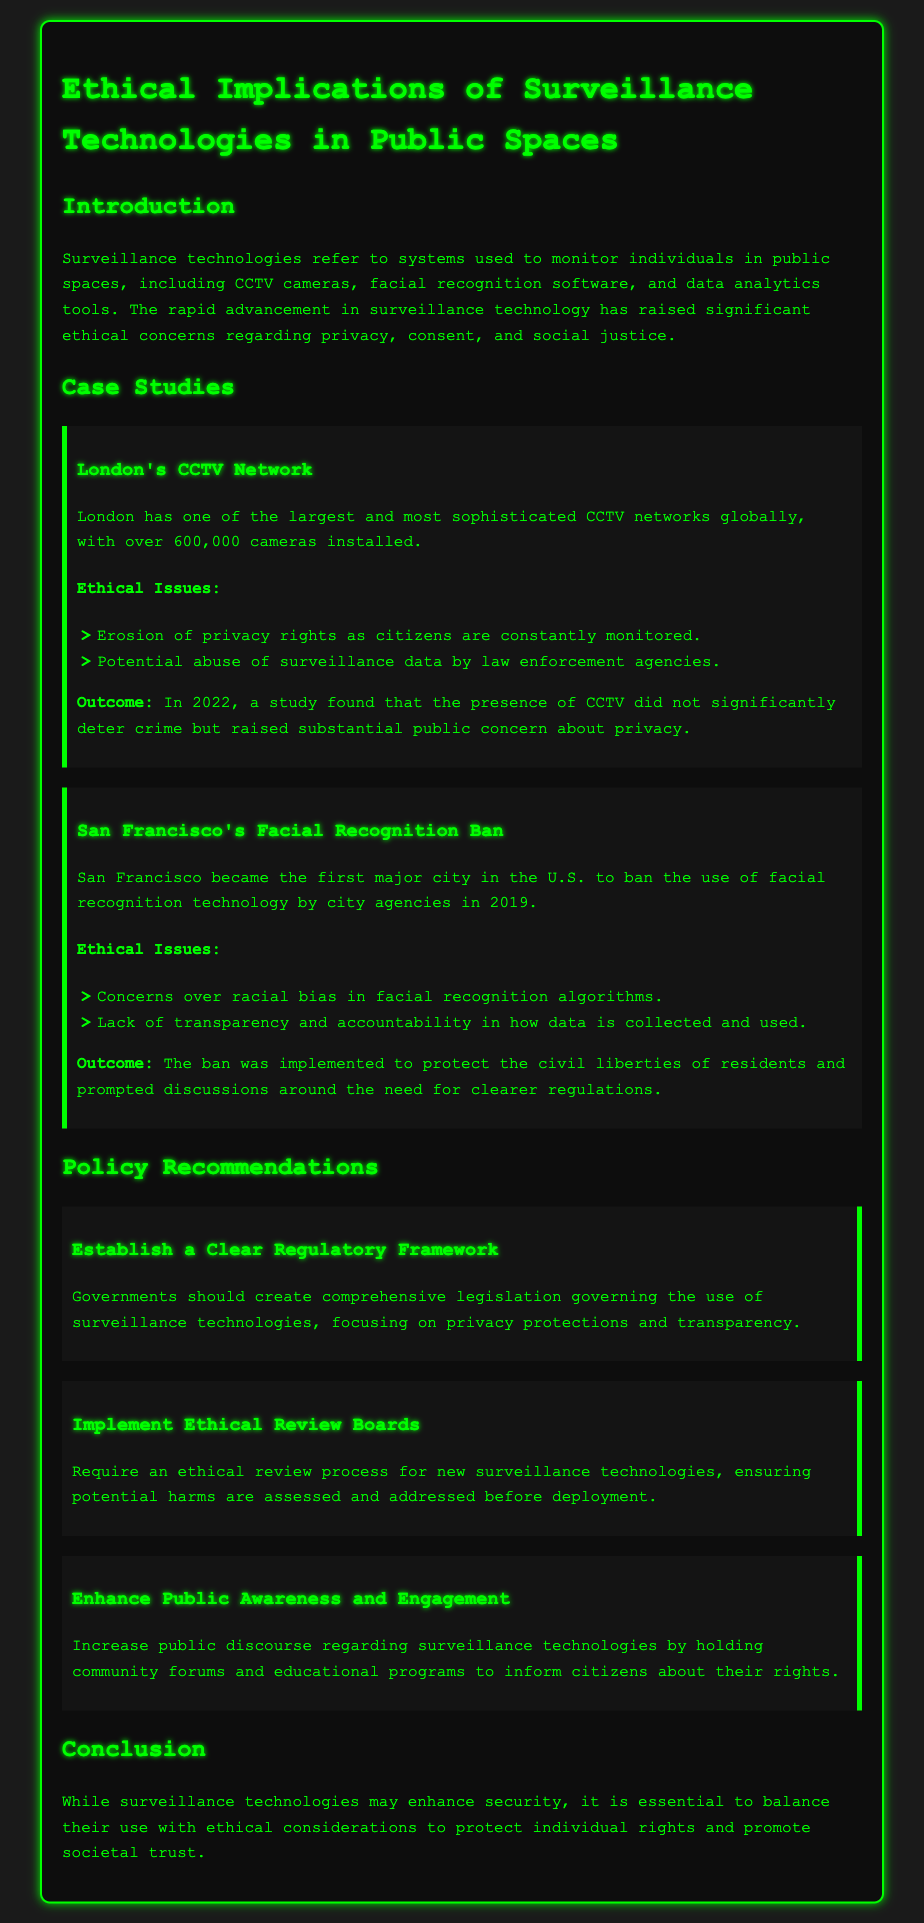What is the name of the first major city to ban facial recognition technology? The document states that San Francisco was the first major city in the U.S. to ban facial recognition technology by city agencies.
Answer: San Francisco How many CCTV cameras are installed in London's network? The document mentions that London has over 600,000 cameras installed in its CCTV network.
Answer: 600,000 What year did a study find that CCTV did not significantly deter crime in London? The document indicates that the study was conducted in 2022, examining the effectiveness of CCTV.
Answer: 2022 What are the two ethical issues associated with San Francisco's facial recognition ban? The document lists concerns over racial bias and lack of transparency as the main ethical issues regarding facial recognition.
Answer: Racial bias, lack of transparency What should governments create according to the policy recommendations? The document recommends that governments should establish a clear regulatory framework governing the use of surveillance technologies.
Answer: Clear regulatory framework Why is it important to implement ethical review boards for surveillance technologies? The document suggests that ethical review boards ensure potential harms are assessed and addressed before deployment of new technologies.
Answer: To assess potential harms What is the primary focus of the legislation suggested in the policy recommendations? The document emphasizes that the legislation should focus on privacy protections and transparency in the use of surveillance technologies.
Answer: Privacy protections and transparency What year did San Francisco ban facial recognition technology? The document states that San Francisco banned facial recognition technology in 2019.
Answer: 2019 